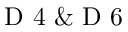Convert formula to latex. <formula><loc_0><loc_0><loc_500><loc_500>D 4 \& D 6</formula> 